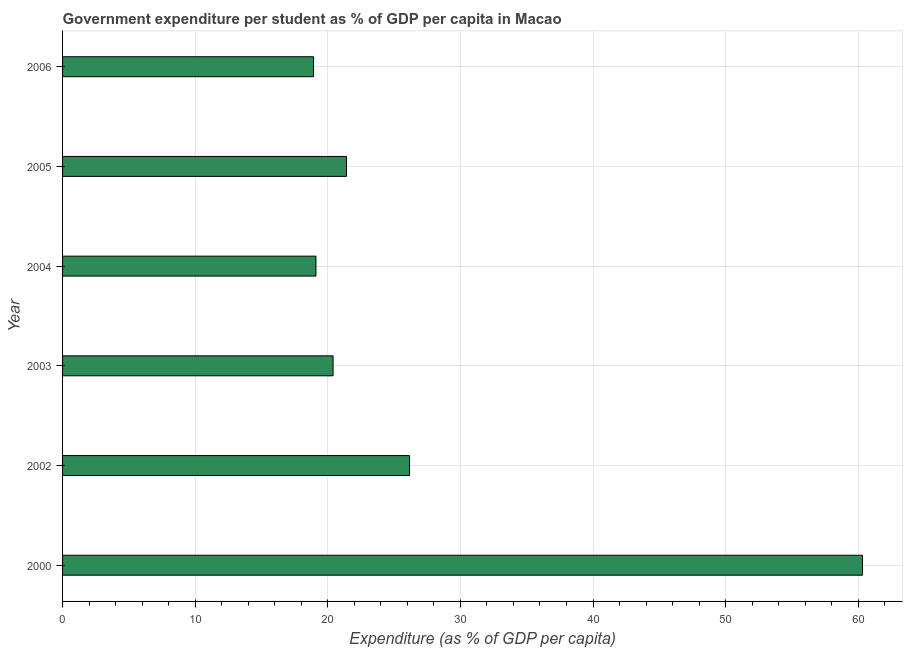Does the graph contain grids?
Keep it short and to the point. Yes. What is the title of the graph?
Your answer should be compact. Government expenditure per student as % of GDP per capita in Macao. What is the label or title of the X-axis?
Give a very brief answer. Expenditure (as % of GDP per capita). What is the label or title of the Y-axis?
Give a very brief answer. Year. What is the government expenditure per student in 2000?
Provide a short and direct response. 60.32. Across all years, what is the maximum government expenditure per student?
Your answer should be very brief. 60.32. Across all years, what is the minimum government expenditure per student?
Your response must be concise. 18.93. In which year was the government expenditure per student minimum?
Provide a succinct answer. 2006. What is the sum of the government expenditure per student?
Make the answer very short. 166.34. What is the difference between the government expenditure per student in 2003 and 2005?
Your response must be concise. -1.01. What is the average government expenditure per student per year?
Offer a very short reply. 27.72. What is the median government expenditure per student?
Provide a short and direct response. 20.91. Do a majority of the years between 2000 and 2005 (inclusive) have government expenditure per student greater than 2 %?
Provide a short and direct response. Yes. What is the ratio of the government expenditure per student in 2000 to that in 2005?
Your response must be concise. 2.82. What is the difference between the highest and the second highest government expenditure per student?
Offer a very short reply. 34.16. Is the sum of the government expenditure per student in 2003 and 2006 greater than the maximum government expenditure per student across all years?
Your answer should be very brief. No. What is the difference between the highest and the lowest government expenditure per student?
Your response must be concise. 41.4. In how many years, is the government expenditure per student greater than the average government expenditure per student taken over all years?
Provide a succinct answer. 1. Are all the bars in the graph horizontal?
Your answer should be very brief. Yes. What is the difference between two consecutive major ticks on the X-axis?
Give a very brief answer. 10. Are the values on the major ticks of X-axis written in scientific E-notation?
Offer a very short reply. No. What is the Expenditure (as % of GDP per capita) of 2000?
Your answer should be compact. 60.32. What is the Expenditure (as % of GDP per capita) of 2002?
Offer a very short reply. 26.17. What is the Expenditure (as % of GDP per capita) of 2003?
Ensure brevity in your answer.  20.4. What is the Expenditure (as % of GDP per capita) in 2004?
Provide a succinct answer. 19.11. What is the Expenditure (as % of GDP per capita) in 2005?
Your answer should be compact. 21.41. What is the Expenditure (as % of GDP per capita) in 2006?
Ensure brevity in your answer.  18.93. What is the difference between the Expenditure (as % of GDP per capita) in 2000 and 2002?
Make the answer very short. 34.16. What is the difference between the Expenditure (as % of GDP per capita) in 2000 and 2003?
Your answer should be compact. 39.92. What is the difference between the Expenditure (as % of GDP per capita) in 2000 and 2004?
Provide a succinct answer. 41.21. What is the difference between the Expenditure (as % of GDP per capita) in 2000 and 2005?
Your answer should be compact. 38.91. What is the difference between the Expenditure (as % of GDP per capita) in 2000 and 2006?
Give a very brief answer. 41.4. What is the difference between the Expenditure (as % of GDP per capita) in 2002 and 2003?
Your answer should be compact. 5.77. What is the difference between the Expenditure (as % of GDP per capita) in 2002 and 2004?
Offer a very short reply. 7.06. What is the difference between the Expenditure (as % of GDP per capita) in 2002 and 2005?
Your response must be concise. 4.75. What is the difference between the Expenditure (as % of GDP per capita) in 2002 and 2006?
Your answer should be compact. 7.24. What is the difference between the Expenditure (as % of GDP per capita) in 2003 and 2004?
Your answer should be compact. 1.29. What is the difference between the Expenditure (as % of GDP per capita) in 2003 and 2005?
Make the answer very short. -1.01. What is the difference between the Expenditure (as % of GDP per capita) in 2003 and 2006?
Keep it short and to the point. 1.47. What is the difference between the Expenditure (as % of GDP per capita) in 2004 and 2005?
Your response must be concise. -2.3. What is the difference between the Expenditure (as % of GDP per capita) in 2004 and 2006?
Make the answer very short. 0.18. What is the difference between the Expenditure (as % of GDP per capita) in 2005 and 2006?
Provide a succinct answer. 2.49. What is the ratio of the Expenditure (as % of GDP per capita) in 2000 to that in 2002?
Your answer should be very brief. 2.31. What is the ratio of the Expenditure (as % of GDP per capita) in 2000 to that in 2003?
Keep it short and to the point. 2.96. What is the ratio of the Expenditure (as % of GDP per capita) in 2000 to that in 2004?
Ensure brevity in your answer.  3.16. What is the ratio of the Expenditure (as % of GDP per capita) in 2000 to that in 2005?
Your answer should be very brief. 2.82. What is the ratio of the Expenditure (as % of GDP per capita) in 2000 to that in 2006?
Your response must be concise. 3.19. What is the ratio of the Expenditure (as % of GDP per capita) in 2002 to that in 2003?
Your answer should be very brief. 1.28. What is the ratio of the Expenditure (as % of GDP per capita) in 2002 to that in 2004?
Your answer should be compact. 1.37. What is the ratio of the Expenditure (as % of GDP per capita) in 2002 to that in 2005?
Your answer should be compact. 1.22. What is the ratio of the Expenditure (as % of GDP per capita) in 2002 to that in 2006?
Give a very brief answer. 1.38. What is the ratio of the Expenditure (as % of GDP per capita) in 2003 to that in 2004?
Your response must be concise. 1.07. What is the ratio of the Expenditure (as % of GDP per capita) in 2003 to that in 2005?
Ensure brevity in your answer.  0.95. What is the ratio of the Expenditure (as % of GDP per capita) in 2003 to that in 2006?
Give a very brief answer. 1.08. What is the ratio of the Expenditure (as % of GDP per capita) in 2004 to that in 2005?
Your answer should be very brief. 0.89. What is the ratio of the Expenditure (as % of GDP per capita) in 2004 to that in 2006?
Provide a short and direct response. 1.01. What is the ratio of the Expenditure (as % of GDP per capita) in 2005 to that in 2006?
Your answer should be compact. 1.13. 